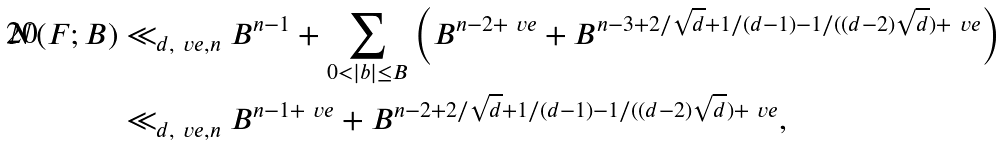Convert formula to latex. <formula><loc_0><loc_0><loc_500><loc_500>N ( F ; B ) & \ll _ { d , \ v e , n } B ^ { n - 1 } + \sum _ { 0 < | b | \leq B } \left ( B ^ { n - 2 + \ v e } + B ^ { n - 3 + 2 / \sqrt { d } + 1 / ( d - 1 ) - 1 / ( ( d - 2 ) \sqrt { d } ) + \ v e } \right ) \\ & \ll _ { d , \ v e , n } B ^ { n - 1 + \ v e } + B ^ { n - 2 + 2 / \sqrt { d } + 1 / ( d - 1 ) - 1 / ( ( d - 2 ) \sqrt { d } ) + \ v e } ,</formula> 